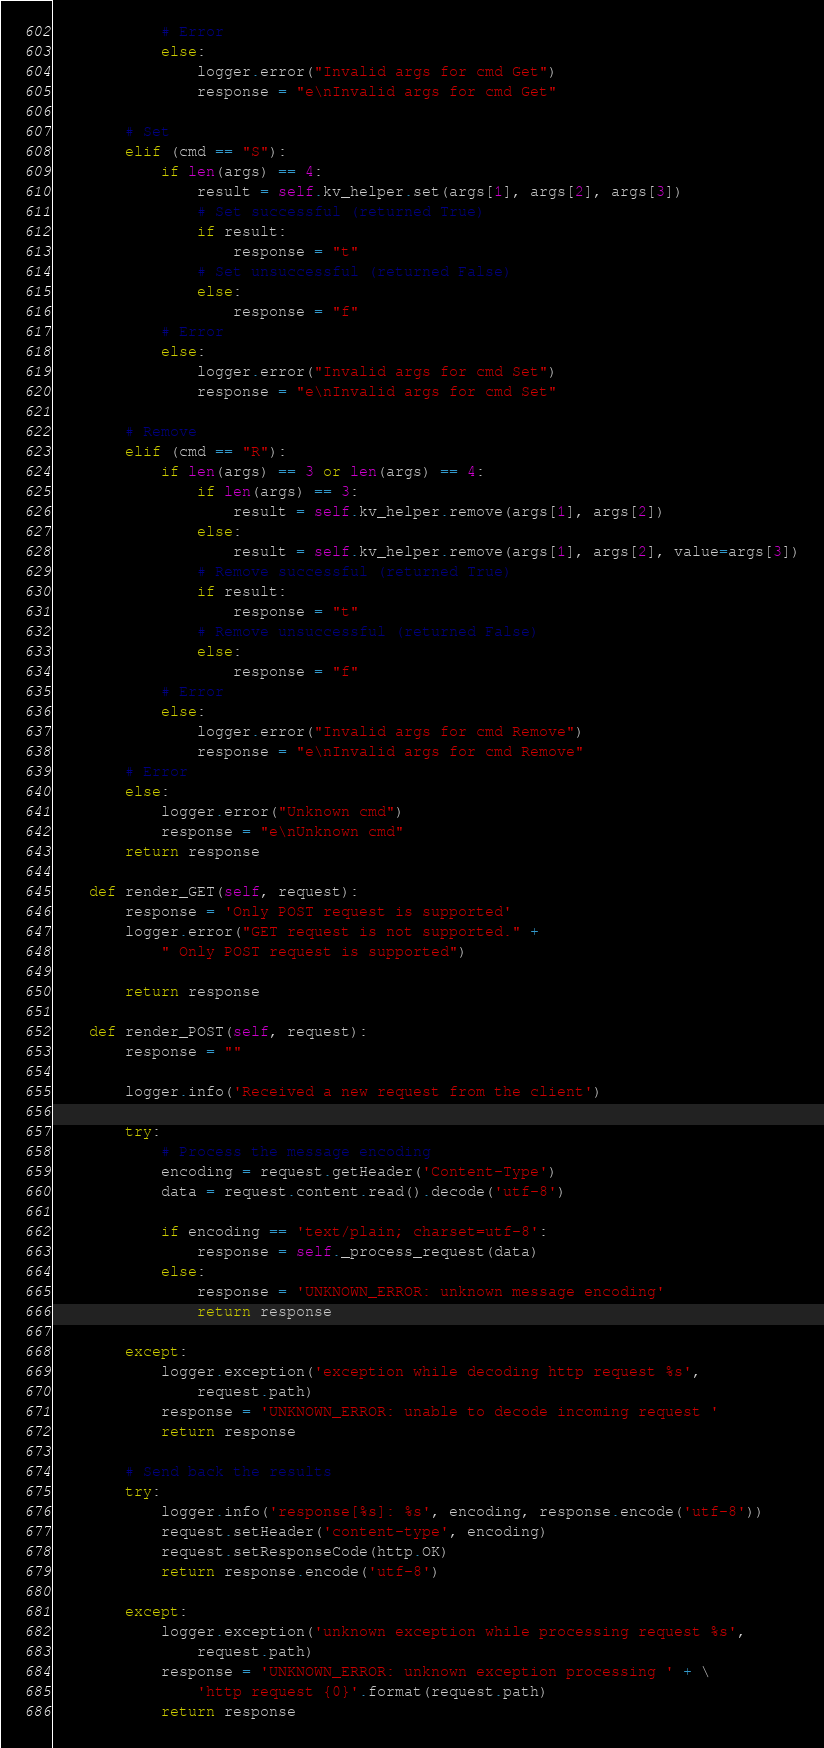<code> <loc_0><loc_0><loc_500><loc_500><_Python_>            # Error
            else:
                logger.error("Invalid args for cmd Get")
                response = "e\nInvalid args for cmd Get"

        # Set
        elif (cmd == "S"):
            if len(args) == 4:
                result = self.kv_helper.set(args[1], args[2], args[3])
                # Set successful (returned True)
                if result:
                    response = "t"
                # Set unsuccessful (returned False)
                else:
                    response = "f"
            # Error
            else:
                logger.error("Invalid args for cmd Set")
                response = "e\nInvalid args for cmd Set"

        # Remove
        elif (cmd == "R"):
            if len(args) == 3 or len(args) == 4:
                if len(args) == 3:
                    result = self.kv_helper.remove(args[1], args[2])
                else:
                    result = self.kv_helper.remove(args[1], args[2], value=args[3])
                # Remove successful (returned True)
                if result:
                    response = "t"
                # Remove unsuccessful (returned False)
                else:
                    response = "f"
            # Error
            else:
                logger.error("Invalid args for cmd Remove")
                response = "e\nInvalid args for cmd Remove"
        # Error
        else:
            logger.error("Unknown cmd")
            response = "e\nUnknown cmd"
        return response

    def render_GET(self, request):
        response = 'Only POST request is supported'
        logger.error("GET request is not supported." +
            " Only POST request is supported")

        return response

    def render_POST(self, request):
        response = ""

        logger.info('Received a new request from the client')

        try:
            # Process the message encoding
            encoding = request.getHeader('Content-Type')
            data = request.content.read().decode('utf-8')

            if encoding == 'text/plain; charset=utf-8':
                response = self._process_request(data)
            else:
                response = 'UNKNOWN_ERROR: unknown message encoding'
                return response

        except:
            logger.exception('exception while decoding http request %s',
                request.path)
            response = 'UNKNOWN_ERROR: unable to decode incoming request '
            return response

        # Send back the results
        try:
            logger.info('response[%s]: %s', encoding, response.encode('utf-8'))
            request.setHeader('content-type', encoding)
            request.setResponseCode(http.OK)
            return response.encode('utf-8')

        except:
            logger.exception('unknown exception while processing request %s',
                request.path)
            response = 'UNKNOWN_ERROR: unknown exception processing ' + \
                'http request {0}'.format(request.path)
            return response
</code> 